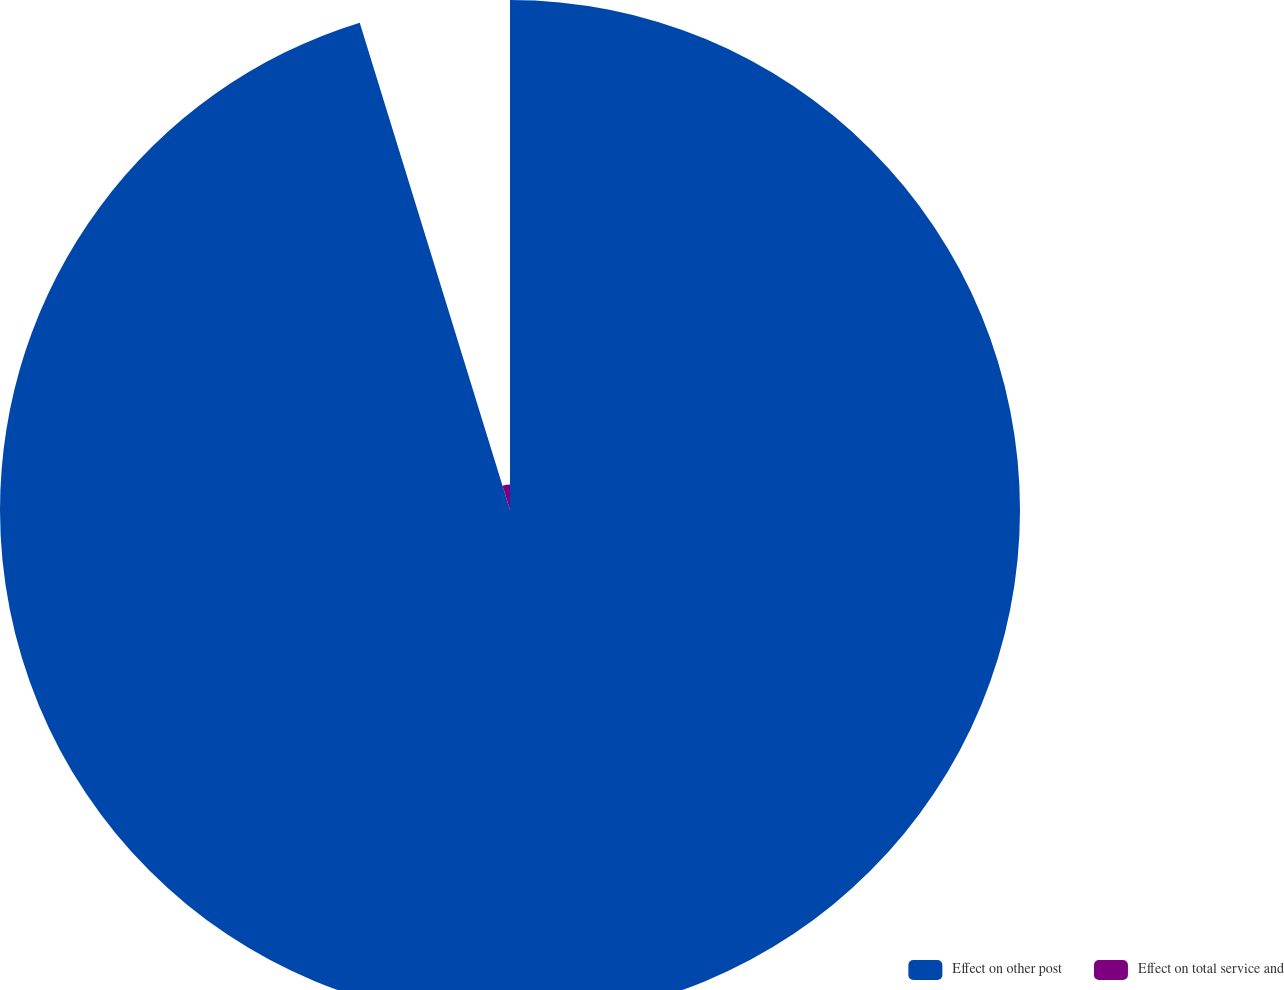<chart> <loc_0><loc_0><loc_500><loc_500><pie_chart><fcel>Effect on other post<fcel>Effect on total service and<nl><fcel>95.24%<fcel>4.76%<nl></chart> 